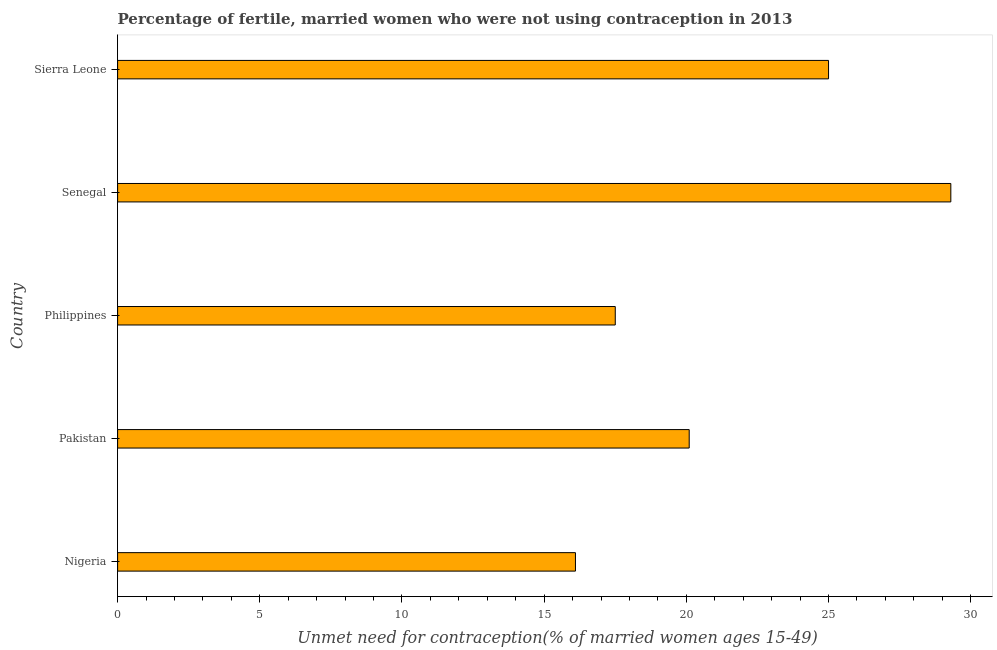Does the graph contain any zero values?
Ensure brevity in your answer.  No. Does the graph contain grids?
Offer a very short reply. No. What is the title of the graph?
Give a very brief answer. Percentage of fertile, married women who were not using contraception in 2013. What is the label or title of the X-axis?
Offer a terse response.  Unmet need for contraception(% of married women ages 15-49). What is the label or title of the Y-axis?
Your answer should be very brief. Country. What is the number of married women who are not using contraception in Philippines?
Ensure brevity in your answer.  17.5. Across all countries, what is the maximum number of married women who are not using contraception?
Offer a terse response. 29.3. Across all countries, what is the minimum number of married women who are not using contraception?
Your response must be concise. 16.1. In which country was the number of married women who are not using contraception maximum?
Provide a short and direct response. Senegal. In which country was the number of married women who are not using contraception minimum?
Your answer should be very brief. Nigeria. What is the sum of the number of married women who are not using contraception?
Offer a terse response. 108. What is the average number of married women who are not using contraception per country?
Offer a terse response. 21.6. What is the median number of married women who are not using contraception?
Ensure brevity in your answer.  20.1. In how many countries, is the number of married women who are not using contraception greater than 15 %?
Your response must be concise. 5. What is the ratio of the number of married women who are not using contraception in Philippines to that in Senegal?
Make the answer very short. 0.6. Is the number of married women who are not using contraception in Nigeria less than that in Pakistan?
Offer a very short reply. Yes. In how many countries, is the number of married women who are not using contraception greater than the average number of married women who are not using contraception taken over all countries?
Offer a very short reply. 2. Are all the bars in the graph horizontal?
Keep it short and to the point. Yes. How many countries are there in the graph?
Your answer should be compact. 5. What is the difference between two consecutive major ticks on the X-axis?
Keep it short and to the point. 5. Are the values on the major ticks of X-axis written in scientific E-notation?
Your response must be concise. No. What is the  Unmet need for contraception(% of married women ages 15-49) of Pakistan?
Your answer should be compact. 20.1. What is the  Unmet need for contraception(% of married women ages 15-49) of Senegal?
Provide a succinct answer. 29.3. What is the  Unmet need for contraception(% of married women ages 15-49) in Sierra Leone?
Keep it short and to the point. 25. What is the difference between the  Unmet need for contraception(% of married women ages 15-49) in Nigeria and Sierra Leone?
Ensure brevity in your answer.  -8.9. What is the difference between the  Unmet need for contraception(% of married women ages 15-49) in Pakistan and Philippines?
Give a very brief answer. 2.6. What is the difference between the  Unmet need for contraception(% of married women ages 15-49) in Pakistan and Senegal?
Provide a short and direct response. -9.2. What is the difference between the  Unmet need for contraception(% of married women ages 15-49) in Pakistan and Sierra Leone?
Offer a terse response. -4.9. What is the difference between the  Unmet need for contraception(% of married women ages 15-49) in Philippines and Senegal?
Make the answer very short. -11.8. What is the difference between the  Unmet need for contraception(% of married women ages 15-49) in Senegal and Sierra Leone?
Give a very brief answer. 4.3. What is the ratio of the  Unmet need for contraception(% of married women ages 15-49) in Nigeria to that in Pakistan?
Your response must be concise. 0.8. What is the ratio of the  Unmet need for contraception(% of married women ages 15-49) in Nigeria to that in Philippines?
Make the answer very short. 0.92. What is the ratio of the  Unmet need for contraception(% of married women ages 15-49) in Nigeria to that in Senegal?
Your response must be concise. 0.55. What is the ratio of the  Unmet need for contraception(% of married women ages 15-49) in Nigeria to that in Sierra Leone?
Keep it short and to the point. 0.64. What is the ratio of the  Unmet need for contraception(% of married women ages 15-49) in Pakistan to that in Philippines?
Provide a short and direct response. 1.15. What is the ratio of the  Unmet need for contraception(% of married women ages 15-49) in Pakistan to that in Senegal?
Provide a short and direct response. 0.69. What is the ratio of the  Unmet need for contraception(% of married women ages 15-49) in Pakistan to that in Sierra Leone?
Make the answer very short. 0.8. What is the ratio of the  Unmet need for contraception(% of married women ages 15-49) in Philippines to that in Senegal?
Give a very brief answer. 0.6. What is the ratio of the  Unmet need for contraception(% of married women ages 15-49) in Senegal to that in Sierra Leone?
Provide a short and direct response. 1.17. 